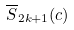Convert formula to latex. <formula><loc_0><loc_0><loc_500><loc_500>\overline { S } _ { 2 k + 1 } ( c )</formula> 